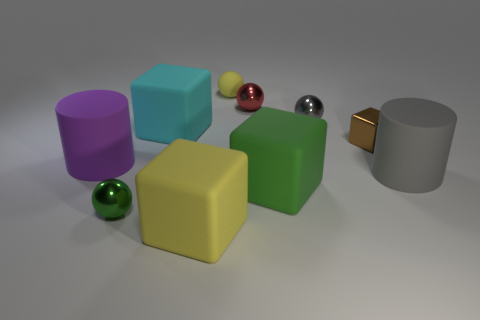Are there any large gray things that have the same material as the yellow block?
Ensure brevity in your answer.  Yes. What shape is the object that is the same color as the matte ball?
Your response must be concise. Cube. Are there fewer small gray balls behind the small yellow ball than small green shiny blocks?
Provide a succinct answer. No. There is a rubber block that is in front of the green rubber block; is its size the same as the gray metal sphere?
Offer a very short reply. No. How many purple things have the same shape as the gray matte thing?
Give a very brief answer. 1. There is a ball that is made of the same material as the big cyan object; what size is it?
Your answer should be very brief. Small. Are there an equal number of cyan blocks in front of the brown metal thing and small red objects?
Your answer should be very brief. No. There is a yellow object in front of the small yellow matte object; does it have the same shape as the green object that is to the right of the yellow block?
Offer a terse response. Yes. There is a small gray thing that is the same shape as the small red metallic object; what is it made of?
Your response must be concise. Metal. What color is the cube that is on the left side of the yellow matte sphere and behind the tiny green thing?
Ensure brevity in your answer.  Cyan. 